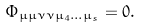<formula> <loc_0><loc_0><loc_500><loc_500>\Phi _ { \mu \mu \nu \nu \mu _ { 4 } \dots \mu _ { s } } = 0 .</formula> 